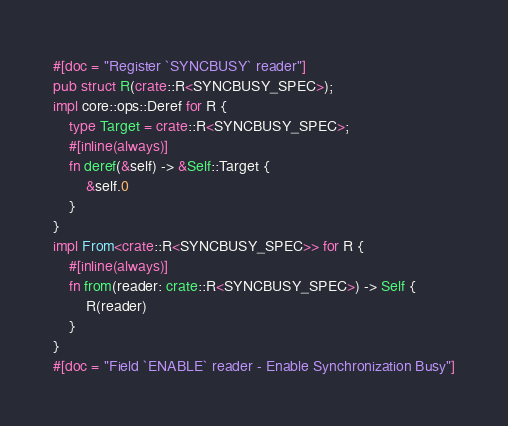<code> <loc_0><loc_0><loc_500><loc_500><_Rust_>#[doc = "Register `SYNCBUSY` reader"]
pub struct R(crate::R<SYNCBUSY_SPEC>);
impl core::ops::Deref for R {
    type Target = crate::R<SYNCBUSY_SPEC>;
    #[inline(always)]
    fn deref(&self) -> &Self::Target {
        &self.0
    }
}
impl From<crate::R<SYNCBUSY_SPEC>> for R {
    #[inline(always)]
    fn from(reader: crate::R<SYNCBUSY_SPEC>) -> Self {
        R(reader)
    }
}
#[doc = "Field `ENABLE` reader - Enable Synchronization Busy"]</code> 